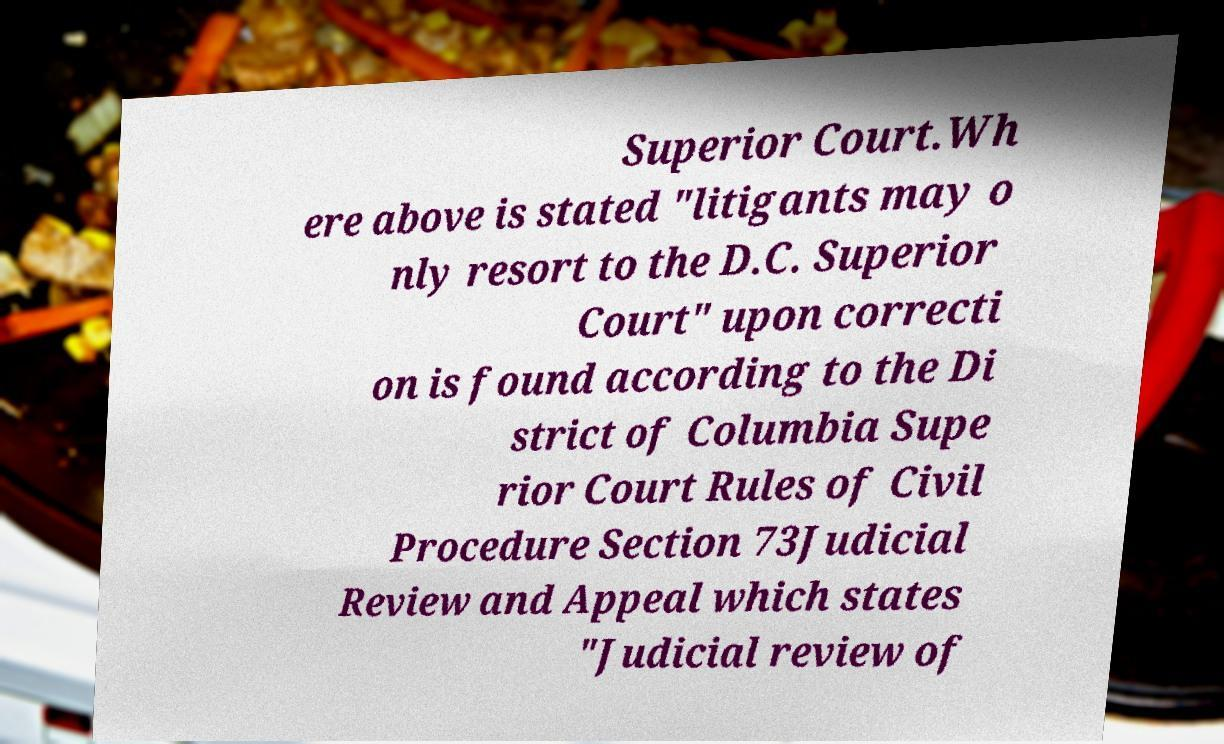Please read and relay the text visible in this image. What does it say? Superior Court.Wh ere above is stated "litigants may o nly resort to the D.C. Superior Court" upon correcti on is found according to the Di strict of Columbia Supe rior Court Rules of Civil Procedure Section 73Judicial Review and Appeal which states "Judicial review of 